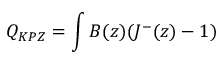Convert formula to latex. <formula><loc_0><loc_0><loc_500><loc_500>Q _ { K P Z } = \int B ( z ) ( J ^ { - } ( z ) - 1 )</formula> 